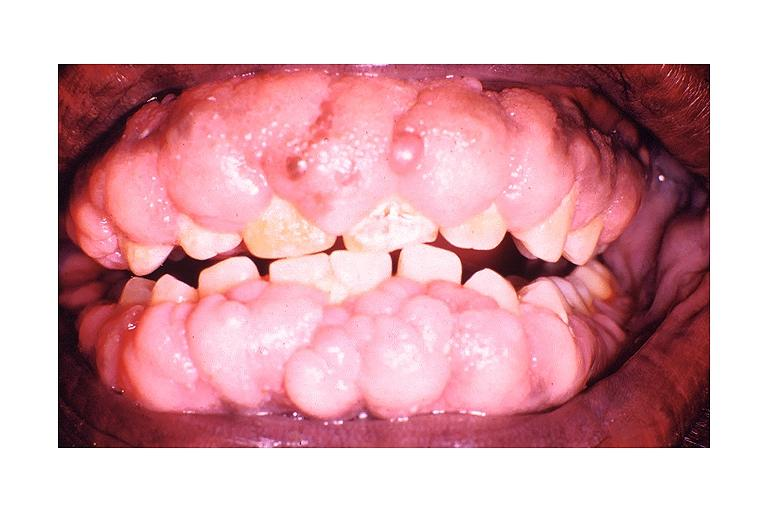what is present?
Answer the question using a single word or phrase. Oral 